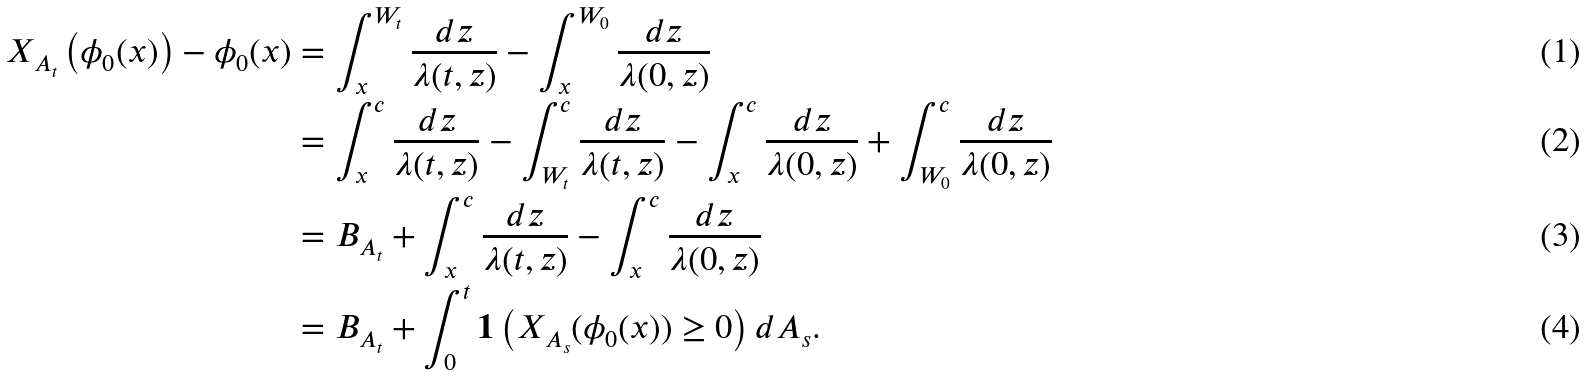<formula> <loc_0><loc_0><loc_500><loc_500>X _ { A _ { t } } \left ( \phi _ { 0 } ( x ) \right ) - \phi _ { 0 } ( x ) & = \int _ { x } ^ { W _ { t } } \frac { d z } { \lambda ( t , z ) } - \int _ { x } ^ { W _ { 0 } } \frac { d z } { \lambda ( 0 , z ) } \\ & = \int _ { x } ^ { c } \frac { d z } { \lambda ( t , z ) } - \int _ { W _ { t } } ^ { c } \frac { d z } { \lambda ( t , z ) } - \int _ { x } ^ { c } \frac { d z } { \lambda ( 0 , z ) } + \int _ { W _ { 0 } } ^ { c } \frac { d z } { \lambda ( 0 , z ) } \\ & = B _ { A _ { t } } + \int _ { x } ^ { c } \frac { d z } { \lambda ( t , z ) } - \int _ { x } ^ { c } \frac { d z } { \lambda ( 0 , z ) } \\ & = B _ { A _ { t } } + \int _ { 0 } ^ { t } { \mathbf 1 } \left ( X _ { A _ { s } } ( \phi _ { 0 } ( x ) ) \geq 0 \right ) d A _ { s } .</formula> 